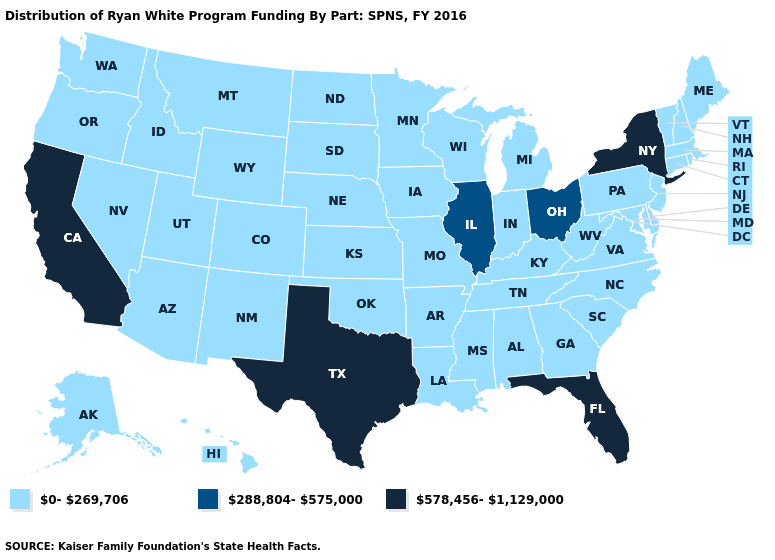Among the states that border Rhode Island , which have the lowest value?
Concise answer only. Connecticut, Massachusetts. Name the states that have a value in the range 288,804-575,000?
Give a very brief answer. Illinois, Ohio. Is the legend a continuous bar?
Answer briefly. No. What is the value of Arizona?
Keep it brief. 0-269,706. Name the states that have a value in the range 0-269,706?
Keep it brief. Alabama, Alaska, Arizona, Arkansas, Colorado, Connecticut, Delaware, Georgia, Hawaii, Idaho, Indiana, Iowa, Kansas, Kentucky, Louisiana, Maine, Maryland, Massachusetts, Michigan, Minnesota, Mississippi, Missouri, Montana, Nebraska, Nevada, New Hampshire, New Jersey, New Mexico, North Carolina, North Dakota, Oklahoma, Oregon, Pennsylvania, Rhode Island, South Carolina, South Dakota, Tennessee, Utah, Vermont, Virginia, Washington, West Virginia, Wisconsin, Wyoming. What is the lowest value in the USA?
Quick response, please. 0-269,706. What is the lowest value in the USA?
Answer briefly. 0-269,706. Name the states that have a value in the range 0-269,706?
Short answer required. Alabama, Alaska, Arizona, Arkansas, Colorado, Connecticut, Delaware, Georgia, Hawaii, Idaho, Indiana, Iowa, Kansas, Kentucky, Louisiana, Maine, Maryland, Massachusetts, Michigan, Minnesota, Mississippi, Missouri, Montana, Nebraska, Nevada, New Hampshire, New Jersey, New Mexico, North Carolina, North Dakota, Oklahoma, Oregon, Pennsylvania, Rhode Island, South Carolina, South Dakota, Tennessee, Utah, Vermont, Virginia, Washington, West Virginia, Wisconsin, Wyoming. What is the value of Louisiana?
Be succinct. 0-269,706. What is the highest value in states that border Louisiana?
Quick response, please. 578,456-1,129,000. What is the value of Texas?
Short answer required. 578,456-1,129,000. What is the value of Delaware?
Short answer required. 0-269,706. What is the lowest value in the USA?
Be succinct. 0-269,706. Name the states that have a value in the range 288,804-575,000?
Keep it brief. Illinois, Ohio. 